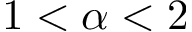<formula> <loc_0><loc_0><loc_500><loc_500>1 < \alpha < 2</formula> 